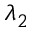<formula> <loc_0><loc_0><loc_500><loc_500>\lambda _ { 2 }</formula> 